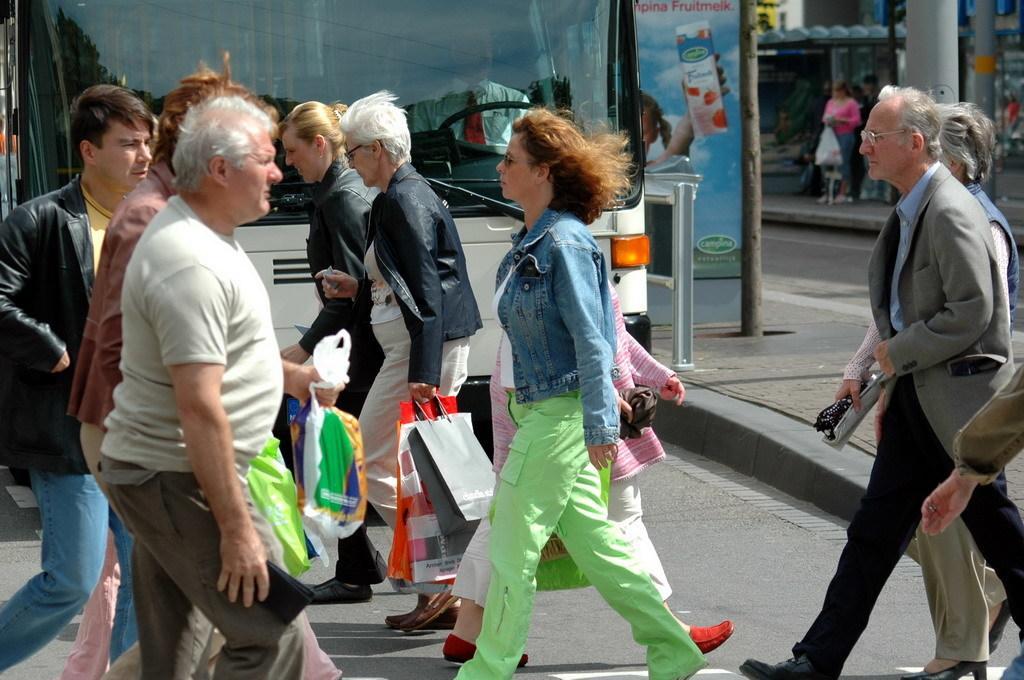Please provide a concise description of this image. In the picture we can see some people are walking on the road by holding some bags and behind them, we can see a bus and besides, we can see a path, on it we can see some board and a pole and on the other side, we can see another road beside it, we can see a path on it we can see a woman standing and beside her we can see some pillar and some shops behind it. 